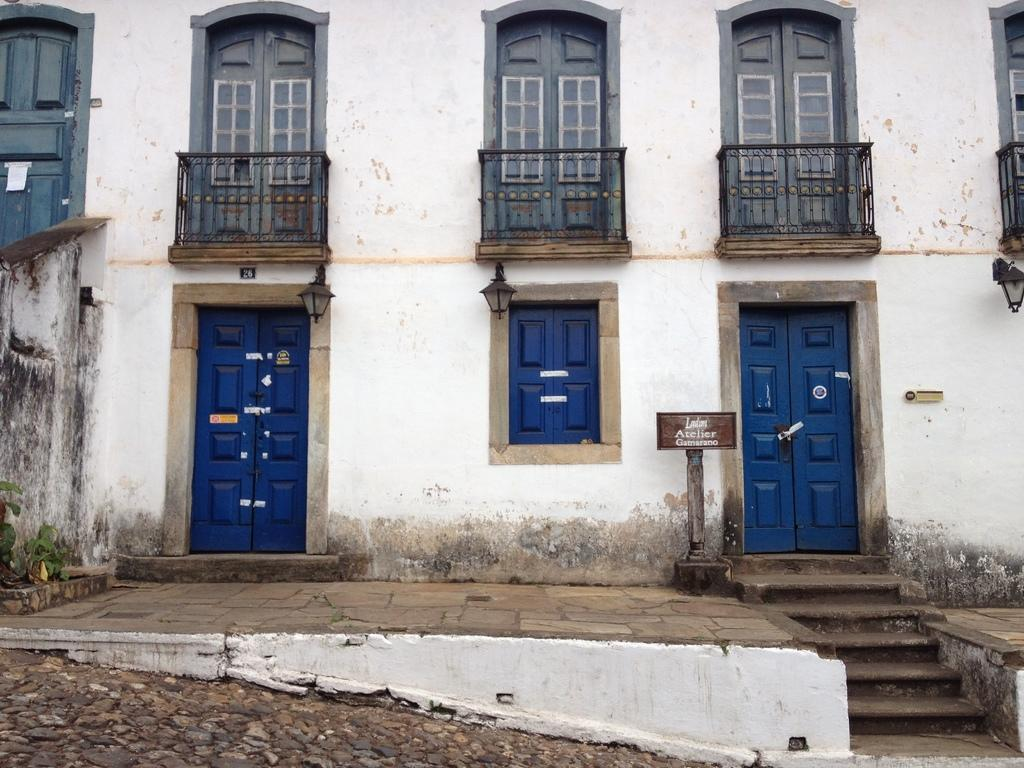What is on the right side of the image? There is a board with text on the right side of the image. What architectural feature can be seen in the image? There are stairs visible in the image. What is in the background of the image? There is a building in the background of the image. What features does the building have? The building has doors and a window. Can you see a boy playing near the sea in the image? There is no boy or sea present in the image. Is there a cub visible in the window of the building? There is no cub present in the image, and the window is not shown with enough detail to determine if a cub could be seen inside. 